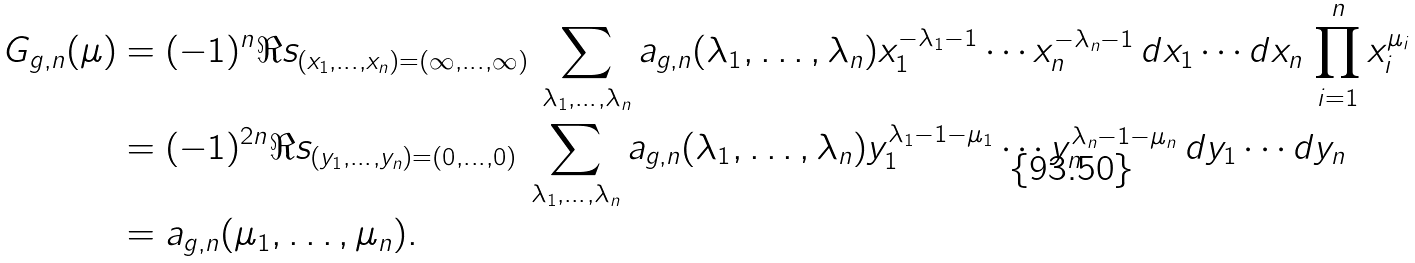Convert formula to latex. <formula><loc_0><loc_0><loc_500><loc_500>G _ { g , n } ( \mu ) & = ( - 1 ) ^ { n } \Re s _ { ( x _ { 1 } , \dots , x _ { n } ) = ( \infty , \dots , \infty ) } \, \sum _ { \lambda _ { 1 } , \dots , \lambda _ { n } } a _ { g , n } ( \lambda _ { 1 } , \dots , \lambda _ { n } ) x _ { 1 } ^ { - \lambda _ { 1 } - 1 } \cdots x _ { n } ^ { - \lambda _ { n } - 1 } \, d x _ { 1 } \cdots d x _ { n } \, \prod _ { i = 1 } ^ { n } x _ { i } ^ { \mu _ { i } } \\ & = ( - 1 ) ^ { 2 n } \Re s _ { ( y _ { 1 } , \dots , y _ { n } ) = ( 0 , \dots , 0 ) } \, \sum _ { \lambda _ { 1 } , \dots , \lambda _ { n } } a _ { g , n } ( \lambda _ { 1 } , \dots , \lambda _ { n } ) y _ { 1 } ^ { \lambda _ { 1 } - 1 - \mu _ { 1 } } \cdots y _ { n } ^ { \lambda _ { n } - 1 - \mu _ { n } } \, d y _ { 1 } \cdots d y _ { n } \\ & = a _ { g , n } ( \mu _ { 1 } , \dots , \mu _ { n } ) .</formula> 